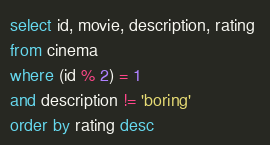<code> <loc_0><loc_0><loc_500><loc_500><_SQL_>

select id, movie, description, rating 
from cinema
where (id % 2) = 1 
and description != 'boring'
order by rating desc</code> 